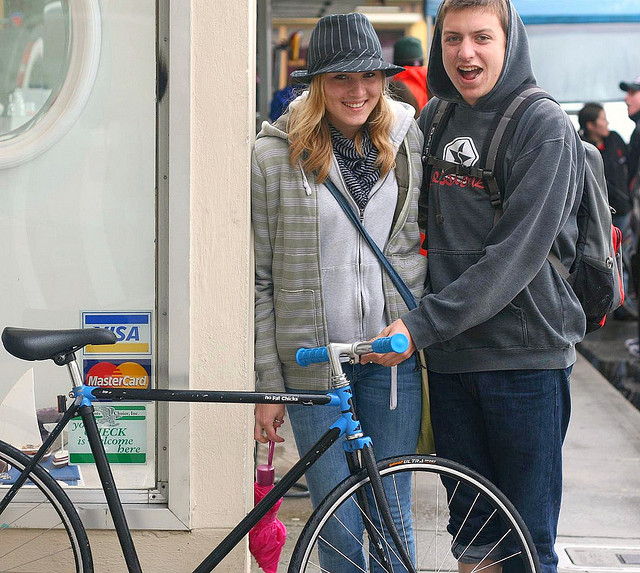Please identify all text content in this image. USA MasterCard here is lcome 